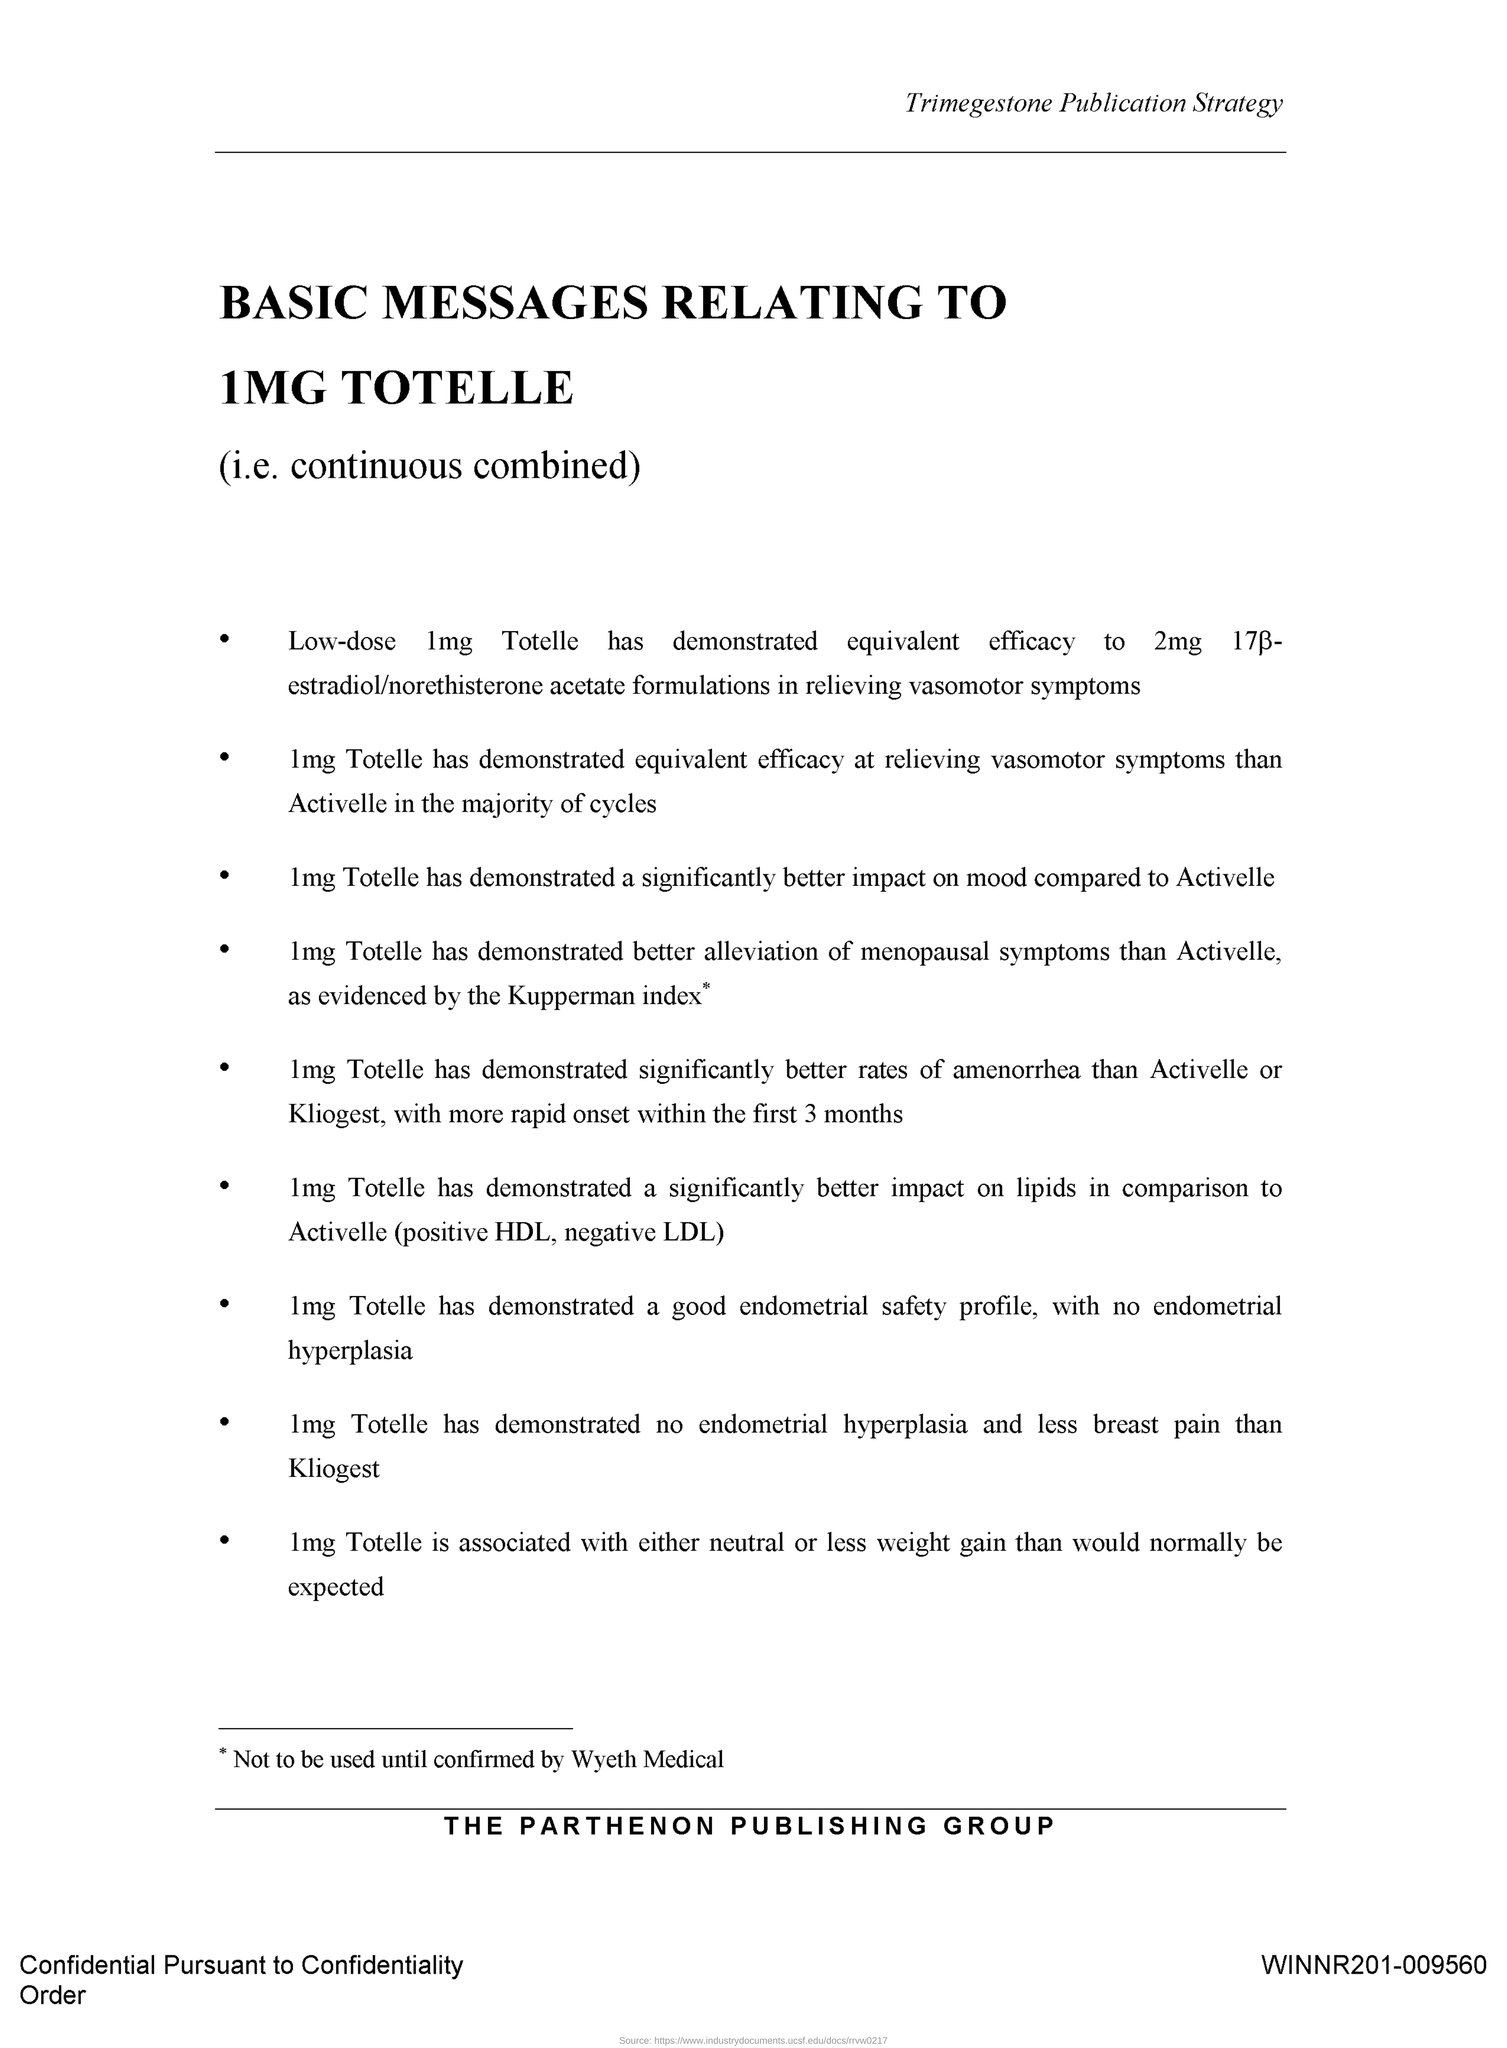Mention a couple of crucial points in this snapshot. The document's header contains the title 'Trimegestone Publication Strategy.' 